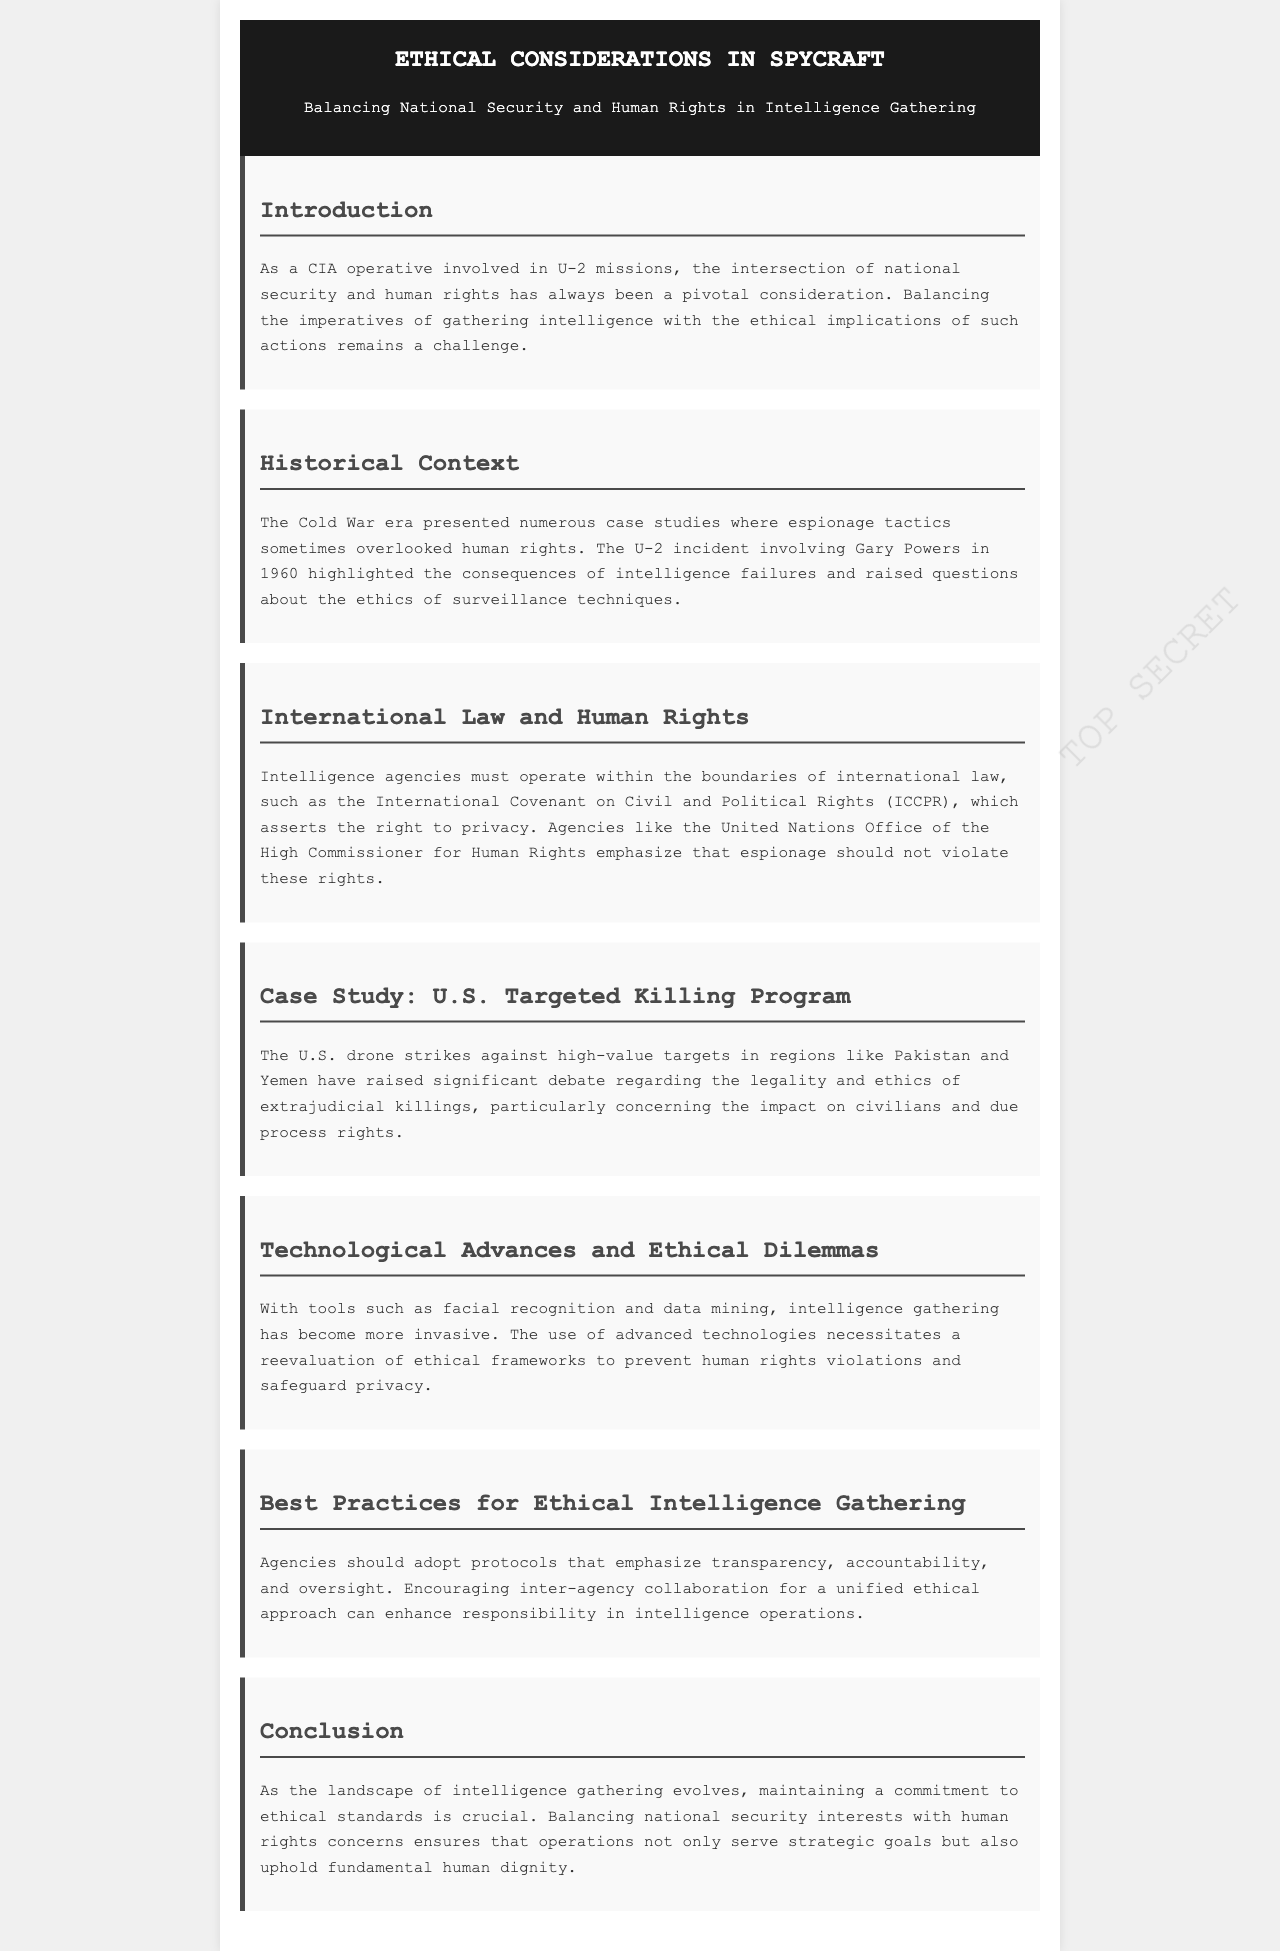What is the primary focus of the newsletter? The primary focus of the newsletter is to discuss the ethical considerations in spycraft, specifically the balance between national security and human rights in intelligence gathering.
Answer: Ethical Considerations in Spycraft What historical case is highlighted in the document? The historical case highlighted in the document is the U-2 incident involving Gary Powers in 1960, which raised questions about espionage ethics.
Answer: U-2 incident involving Gary Powers Which international treaty is mentioned regarding privacy rights? The document refers to the International Covenant on Civil and Political Rights (ICCPR) as a crucial framework for privacy rights in intelligence operations.
Answer: International Covenant on Civil and Political Rights (ICCPR) What technological tools are discussed that raise ethical dilemmas? The newsletter mentions facial recognition and data mining as tools that have become more invasive in intelligence gathering.
Answer: Facial recognition and data mining What is a recommended protocol for ethical intelligence gathering? The newsletter suggests that agencies should emphasize transparency, accountability, and oversight as best practices for ethical intelligence gathering.
Answer: Transparency, accountability, and oversight How does the newsletter describe the impact of U.S. drone strikes? The newsletter describes the U.S. drone strikes as raising debate regarding legality and ethics, specifically concerning civilians and due process rights.
Answer: Legality and ethics Which agency's role is highlighted in emphasizing human rights in espionage? The document mentions the United Nations Office of the High Commissioner for Human Rights as an important agency emphasizing the need for respecting human rights in espionage.
Answer: United Nations Office of the High Commissioner for Human Rights What is the conclusion regarding the future of intelligence gathering? The conclusion stresses the importance of maintaining a commitment to ethical standards as intelligence gathering evolves to ensure the upholding of human dignity.
Answer: Commitment to ethical standards 